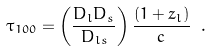<formula> <loc_0><loc_0><loc_500><loc_500>\tau _ { 1 0 0 } = \left ( \frac { D _ { l } D _ { s } } { D _ { l s } } \right ) \frac { ( 1 + z _ { l } ) } { c } \ .</formula> 